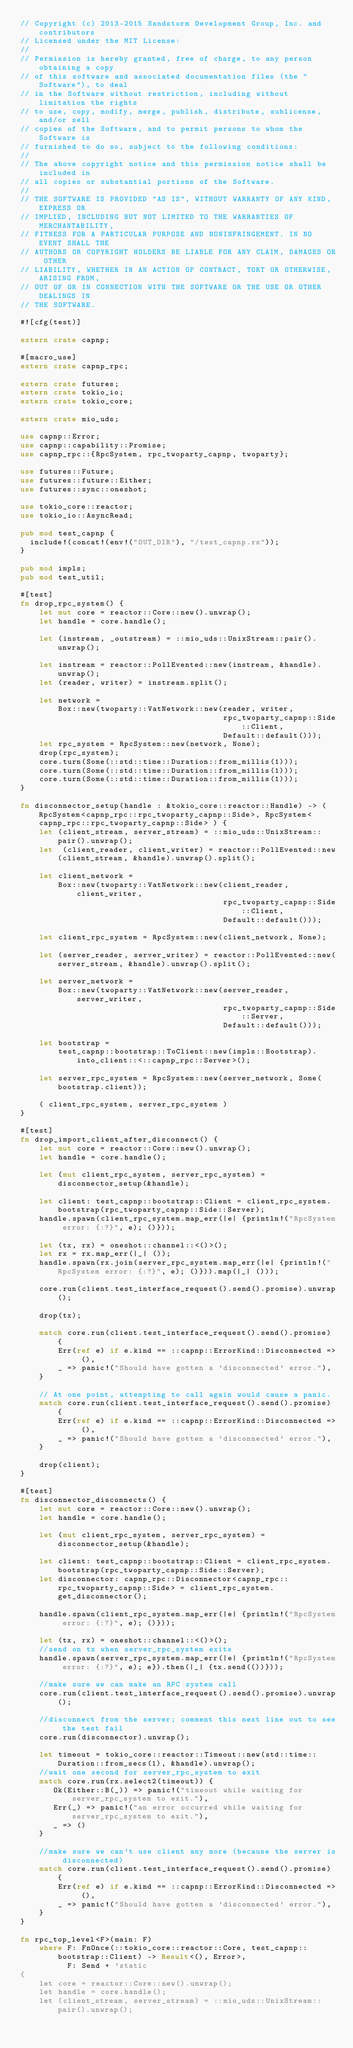<code> <loc_0><loc_0><loc_500><loc_500><_Rust_>// Copyright (c) 2013-2015 Sandstorm Development Group, Inc. and contributors
// Licensed under the MIT License:
//
// Permission is hereby granted, free of charge, to any person obtaining a copy
// of this software and associated documentation files (the "Software"), to deal
// in the Software without restriction, including without limitation the rights
// to use, copy, modify, merge, publish, distribute, sublicense, and/or sell
// copies of the Software, and to permit persons to whom the Software is
// furnished to do so, subject to the following conditions:
//
// The above copyright notice and this permission notice shall be included in
// all copies or substantial portions of the Software.
//
// THE SOFTWARE IS PROVIDED "AS IS", WITHOUT WARRANTY OF ANY KIND, EXPRESS OR
// IMPLIED, INCLUDING BUT NOT LIMITED TO THE WARRANTIES OF MERCHANTABILITY,
// FITNESS FOR A PARTICULAR PURPOSE AND NONINFRINGEMENT. IN NO EVENT SHALL THE
// AUTHORS OR COPYRIGHT HOLDERS BE LIABLE FOR ANY CLAIM, DAMAGES OR OTHER
// LIABILITY, WHETHER IN AN ACTION OF CONTRACT, TORT OR OTHERWISE, ARISING FROM,
// OUT OF OR IN CONNECTION WITH THE SOFTWARE OR THE USE OR OTHER DEALINGS IN
// THE SOFTWARE.

#![cfg(test)]

extern crate capnp;

#[macro_use]
extern crate capnp_rpc;

extern crate futures;
extern crate tokio_io;
extern crate tokio_core;

extern crate mio_uds;

use capnp::Error;
use capnp::capability::Promise;
use capnp_rpc::{RpcSystem, rpc_twoparty_capnp, twoparty};

use futures::Future;
use futures::future::Either;
use futures::sync::oneshot;

use tokio_core::reactor;
use tokio_io::AsyncRead;

pub mod test_capnp {
  include!(concat!(env!("OUT_DIR"), "/test_capnp.rs"));
}

pub mod impls;
pub mod test_util;

#[test]
fn drop_rpc_system() {
    let mut core = reactor::Core::new().unwrap();
    let handle = core.handle();

    let (instream, _outstream) = ::mio_uds::UnixStream::pair().unwrap();

    let instream = reactor::PollEvented::new(instream, &handle).unwrap();
    let (reader, writer) = instream.split();

    let network =
        Box::new(twoparty::VatNetwork::new(reader, writer,
                                           rpc_twoparty_capnp::Side::Client,
                                           Default::default()));
    let rpc_system = RpcSystem::new(network, None);
    drop(rpc_system);
    core.turn(Some(::std::time::Duration::from_millis(1)));
    core.turn(Some(::std::time::Duration::from_millis(1)));
    core.turn(Some(::std::time::Duration::from_millis(1)));
}

fn disconnector_setup(handle : &tokio_core::reactor::Handle) -> ( RpcSystem<capnp_rpc::rpc_twoparty_capnp::Side>, RpcSystem<capnp_rpc::rpc_twoparty_capnp::Side> ) {
    let (client_stream, server_stream) = ::mio_uds::UnixStream::pair().unwrap();
    let  (client_reader, client_writer) = reactor::PollEvented::new(client_stream, &handle).unwrap().split();

    let client_network =
        Box::new(twoparty::VatNetwork::new(client_reader, client_writer,
                                           rpc_twoparty_capnp::Side::Client,
                                           Default::default()));

    let client_rpc_system = RpcSystem::new(client_network, None);

    let (server_reader, server_writer) = reactor::PollEvented::new(server_stream, &handle).unwrap().split();

    let server_network =
        Box::new(twoparty::VatNetwork::new(server_reader, server_writer,
                                           rpc_twoparty_capnp::Side::Server,
                                           Default::default()));

    let bootstrap =
        test_capnp::bootstrap::ToClient::new(impls::Bootstrap).into_client::<::capnp_rpc::Server>();

    let server_rpc_system = RpcSystem::new(server_network, Some(bootstrap.client));

    ( client_rpc_system, server_rpc_system )
}

#[test]
fn drop_import_client_after_disconnect() {
    let mut core = reactor::Core::new().unwrap();
    let handle = core.handle();

    let (mut client_rpc_system, server_rpc_system) = disconnector_setup(&handle);

    let client: test_capnp::bootstrap::Client = client_rpc_system.bootstrap(rpc_twoparty_capnp::Side::Server);
    handle.spawn(client_rpc_system.map_err(|e| {println!("RpcSystem error: {:?}", e); ()}));

    let (tx, rx) = oneshot::channel::<()>();
    let rx = rx.map_err(|_| ());
    handle.spawn(rx.join(server_rpc_system.map_err(|e| {println!("RpcSystem error: {:?}", e); ()})).map(|_| ()));

    core.run(client.test_interface_request().send().promise).unwrap();

    drop(tx);

    match core.run(client.test_interface_request().send().promise) {
        Err(ref e) if e.kind == ::capnp::ErrorKind::Disconnected => (),
        _ => panic!("Should have gotten a 'disconnected' error."),
    }

    // At one point, attempting to call again would cause a panic.
    match core.run(client.test_interface_request().send().promise) {
        Err(ref e) if e.kind == ::capnp::ErrorKind::Disconnected => (),
        _ => panic!("Should have gotten a 'disconnected' error."),
    }

    drop(client);
}

#[test]
fn disconnector_disconnects() {
    let mut core = reactor::Core::new().unwrap();
    let handle = core.handle();

    let (mut client_rpc_system, server_rpc_system) = disconnector_setup(&handle);

    let client: test_capnp::bootstrap::Client = client_rpc_system.bootstrap(rpc_twoparty_capnp::Side::Server);
    let disconnector: capnp_rpc::Disconnector<capnp_rpc::rpc_twoparty_capnp::Side> = client_rpc_system.get_disconnector();

    handle.spawn(client_rpc_system.map_err(|e| {println!("RpcSystem error: {:?}", e); ()}));

    let (tx, rx) = oneshot::channel::<()>();
    //send on tx when server_rpc_system exits
    handle.spawn(server_rpc_system.map_err(|e| {println!("RpcSystem error: {:?}", e); e}).then(|_| {tx.send(())}));

    //make sure we can make an RPC system call
    core.run(client.test_interface_request().send().promise).unwrap();

    //disconnect from the server; comment this next line out to see the test fail
    core.run(disconnector).unwrap();

    let timeout = tokio_core::reactor::Timeout::new(std::time::Duration::from_secs(1), &handle).unwrap();
    //wait one second for server_rpc_system to exit
    match core.run(rx.select2(timeout)) {
       Ok(Either::B(_)) => panic!("timeout while waiting for server_rpc_system to exit."),
       Err(_) => panic!("an error occurred while waiting for server_rpc_system to exit."),
       _ => ()
    }

    //make sure we can't use client any more (because the server is disconnected)
    match core.run(client.test_interface_request().send().promise) {
        Err(ref e) if e.kind == ::capnp::ErrorKind::Disconnected => (),
        _ => panic!("Should have gotten a 'disconnected' error."),
    }
}

fn rpc_top_level<F>(main: F)
    where F: FnOnce(::tokio_core::reactor::Core, test_capnp::bootstrap::Client) -> Result<(), Error>,
          F: Send + 'static
{
    let core = reactor::Core::new().unwrap();
    let handle = core.handle();
    let (client_stream, server_stream) = ::mio_uds::UnixStream::pair().unwrap();

</code> 